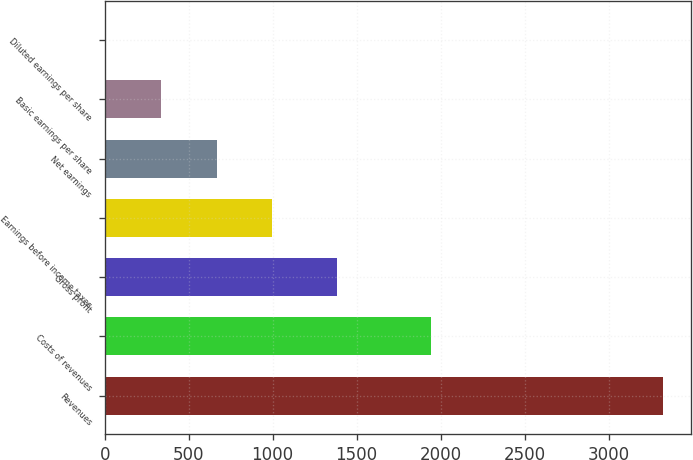Convert chart to OTSL. <chart><loc_0><loc_0><loc_500><loc_500><bar_chart><fcel>Revenues<fcel>Costs of revenues<fcel>Gross profit<fcel>Earnings before income taxes<fcel>Net earnings<fcel>Basic earnings per share<fcel>Diluted earnings per share<nl><fcel>3323.2<fcel>1940.5<fcel>1382.7<fcel>997.76<fcel>665.56<fcel>333.35<fcel>1.15<nl></chart> 